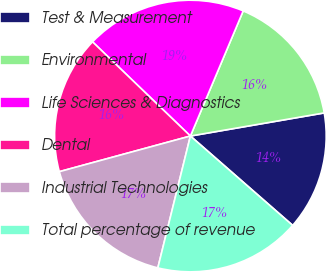Convert chart to OTSL. <chart><loc_0><loc_0><loc_500><loc_500><pie_chart><fcel>Test & Measurement<fcel>Environmental<fcel>Life Sciences & Diagnostics<fcel>Dental<fcel>Industrial Technologies<fcel>Total percentage of revenue<nl><fcel>14.15%<fcel>15.92%<fcel>19.16%<fcel>16.42%<fcel>16.92%<fcel>17.42%<nl></chart> 